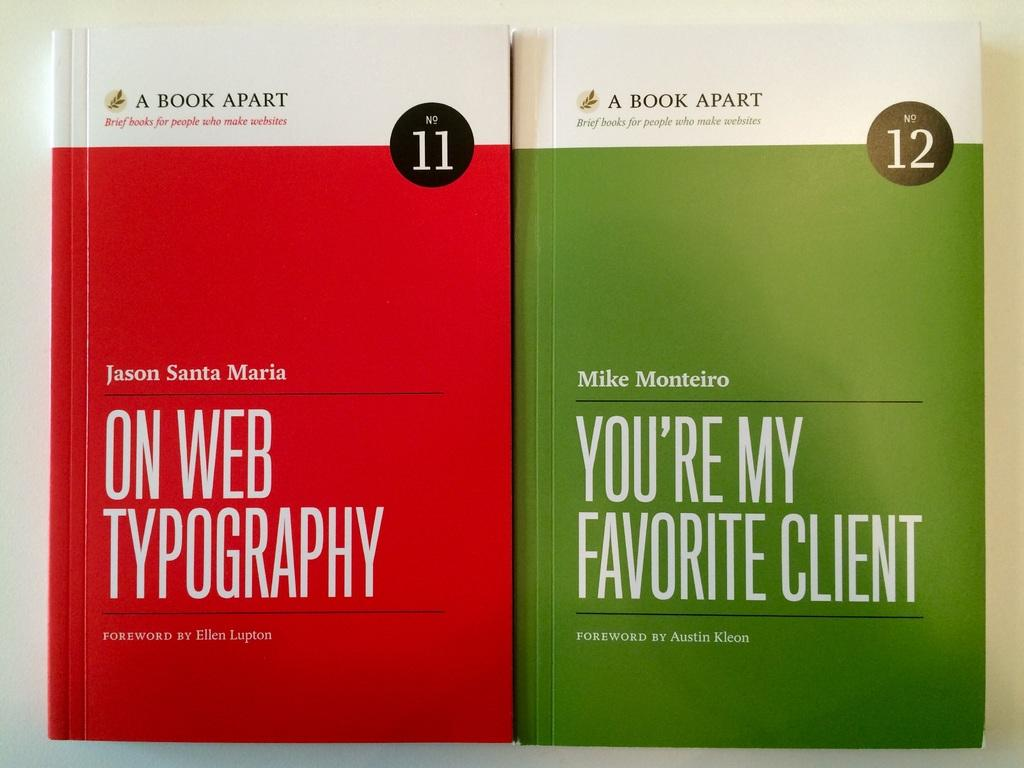<image>
Describe the image concisely. Two books from the A Book Apart series, one by Jason Santa Maria, the other by Mike Monterio. 